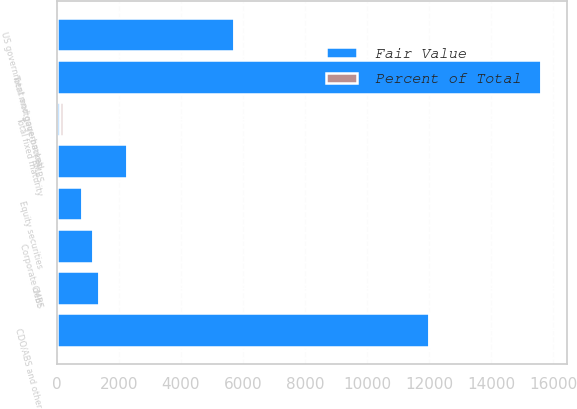Convert chart. <chart><loc_0><loc_0><loc_500><loc_500><stacked_bar_chart><ecel><fcel>US government and government<fcel>Corporate debt<fcel>RMBS<fcel>CMBS<fcel>CDO/ABS and other<fcel>Total mortgage-backed<fcel>Total fixed maturity<fcel>Equity securities<nl><fcel>Fair Value<fcel>5723<fcel>1169<fcel>2263<fcel>1353<fcel>11985<fcel>15601<fcel>97<fcel>834<nl><fcel>Percent of Total<fcel>24<fcel>5<fcel>10<fcel>6<fcel>51<fcel>67<fcel>97<fcel>3<nl></chart> 